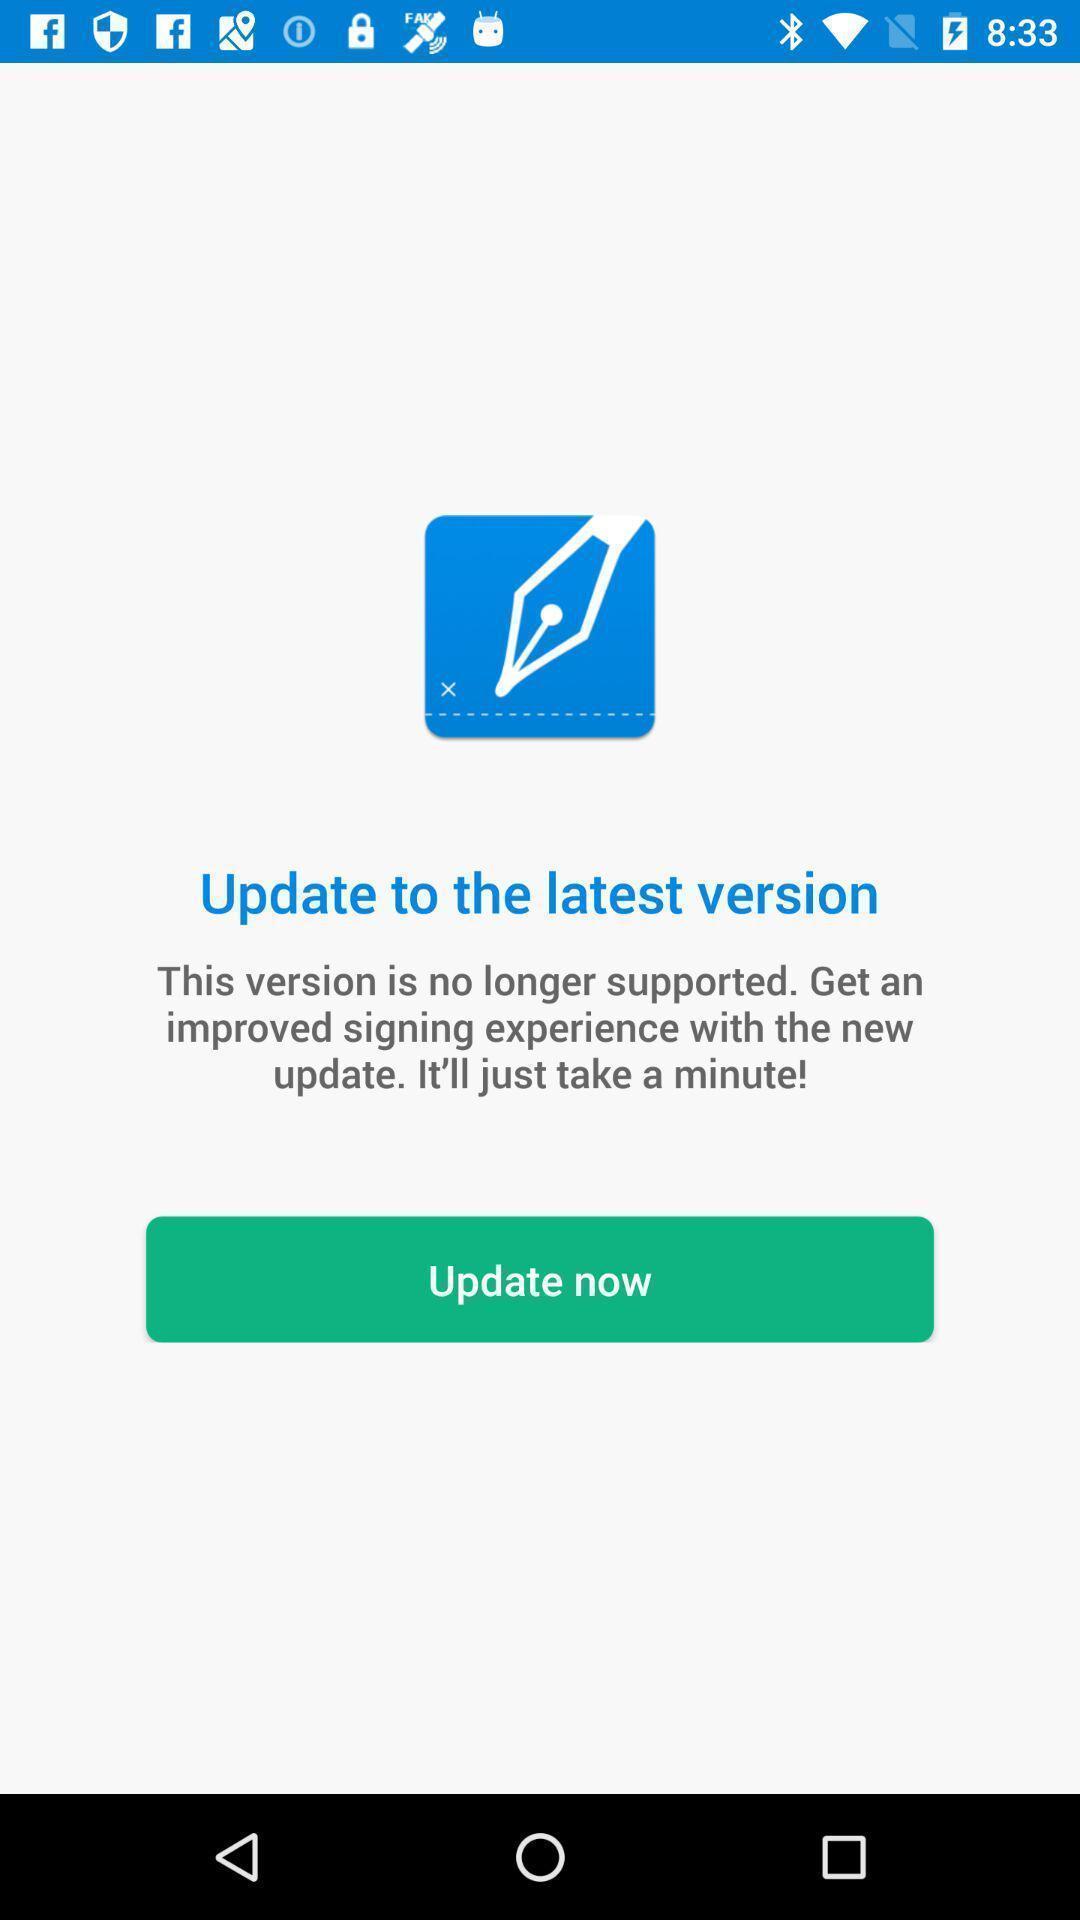Tell me about the visual elements in this screen capture. Screen displaying version information. 